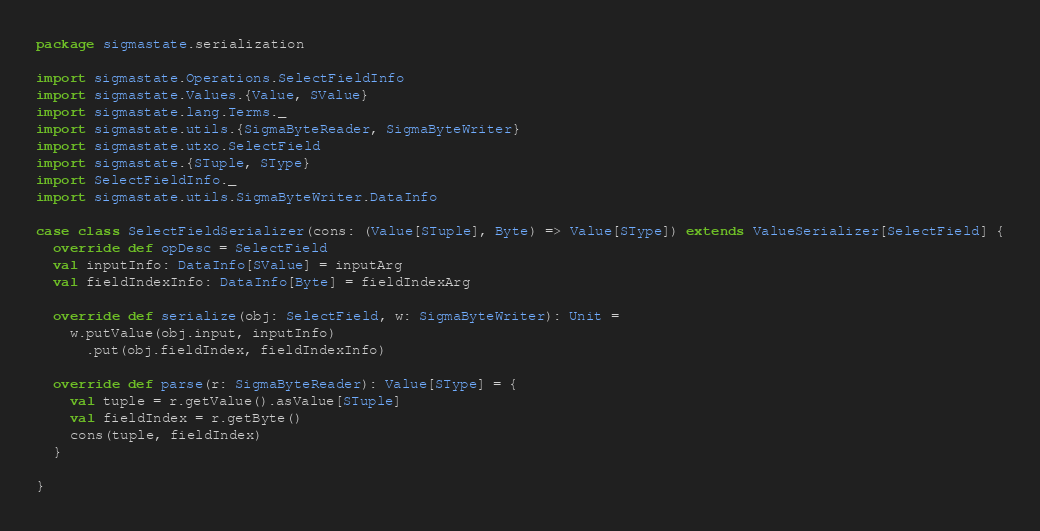Convert code to text. <code><loc_0><loc_0><loc_500><loc_500><_Scala_>package sigmastate.serialization

import sigmastate.Operations.SelectFieldInfo
import sigmastate.Values.{Value, SValue}
import sigmastate.lang.Terms._
import sigmastate.utils.{SigmaByteReader, SigmaByteWriter}
import sigmastate.utxo.SelectField
import sigmastate.{STuple, SType}
import SelectFieldInfo._
import sigmastate.utils.SigmaByteWriter.DataInfo

case class SelectFieldSerializer(cons: (Value[STuple], Byte) => Value[SType]) extends ValueSerializer[SelectField] {
  override def opDesc = SelectField
  val inputInfo: DataInfo[SValue] = inputArg
  val fieldIndexInfo: DataInfo[Byte] = fieldIndexArg

  override def serialize(obj: SelectField, w: SigmaByteWriter): Unit =
    w.putValue(obj.input, inputInfo)
      .put(obj.fieldIndex, fieldIndexInfo)

  override def parse(r: SigmaByteReader): Value[SType] = {
    val tuple = r.getValue().asValue[STuple]
    val fieldIndex = r.getByte()
    cons(tuple, fieldIndex)
  }

}
</code> 